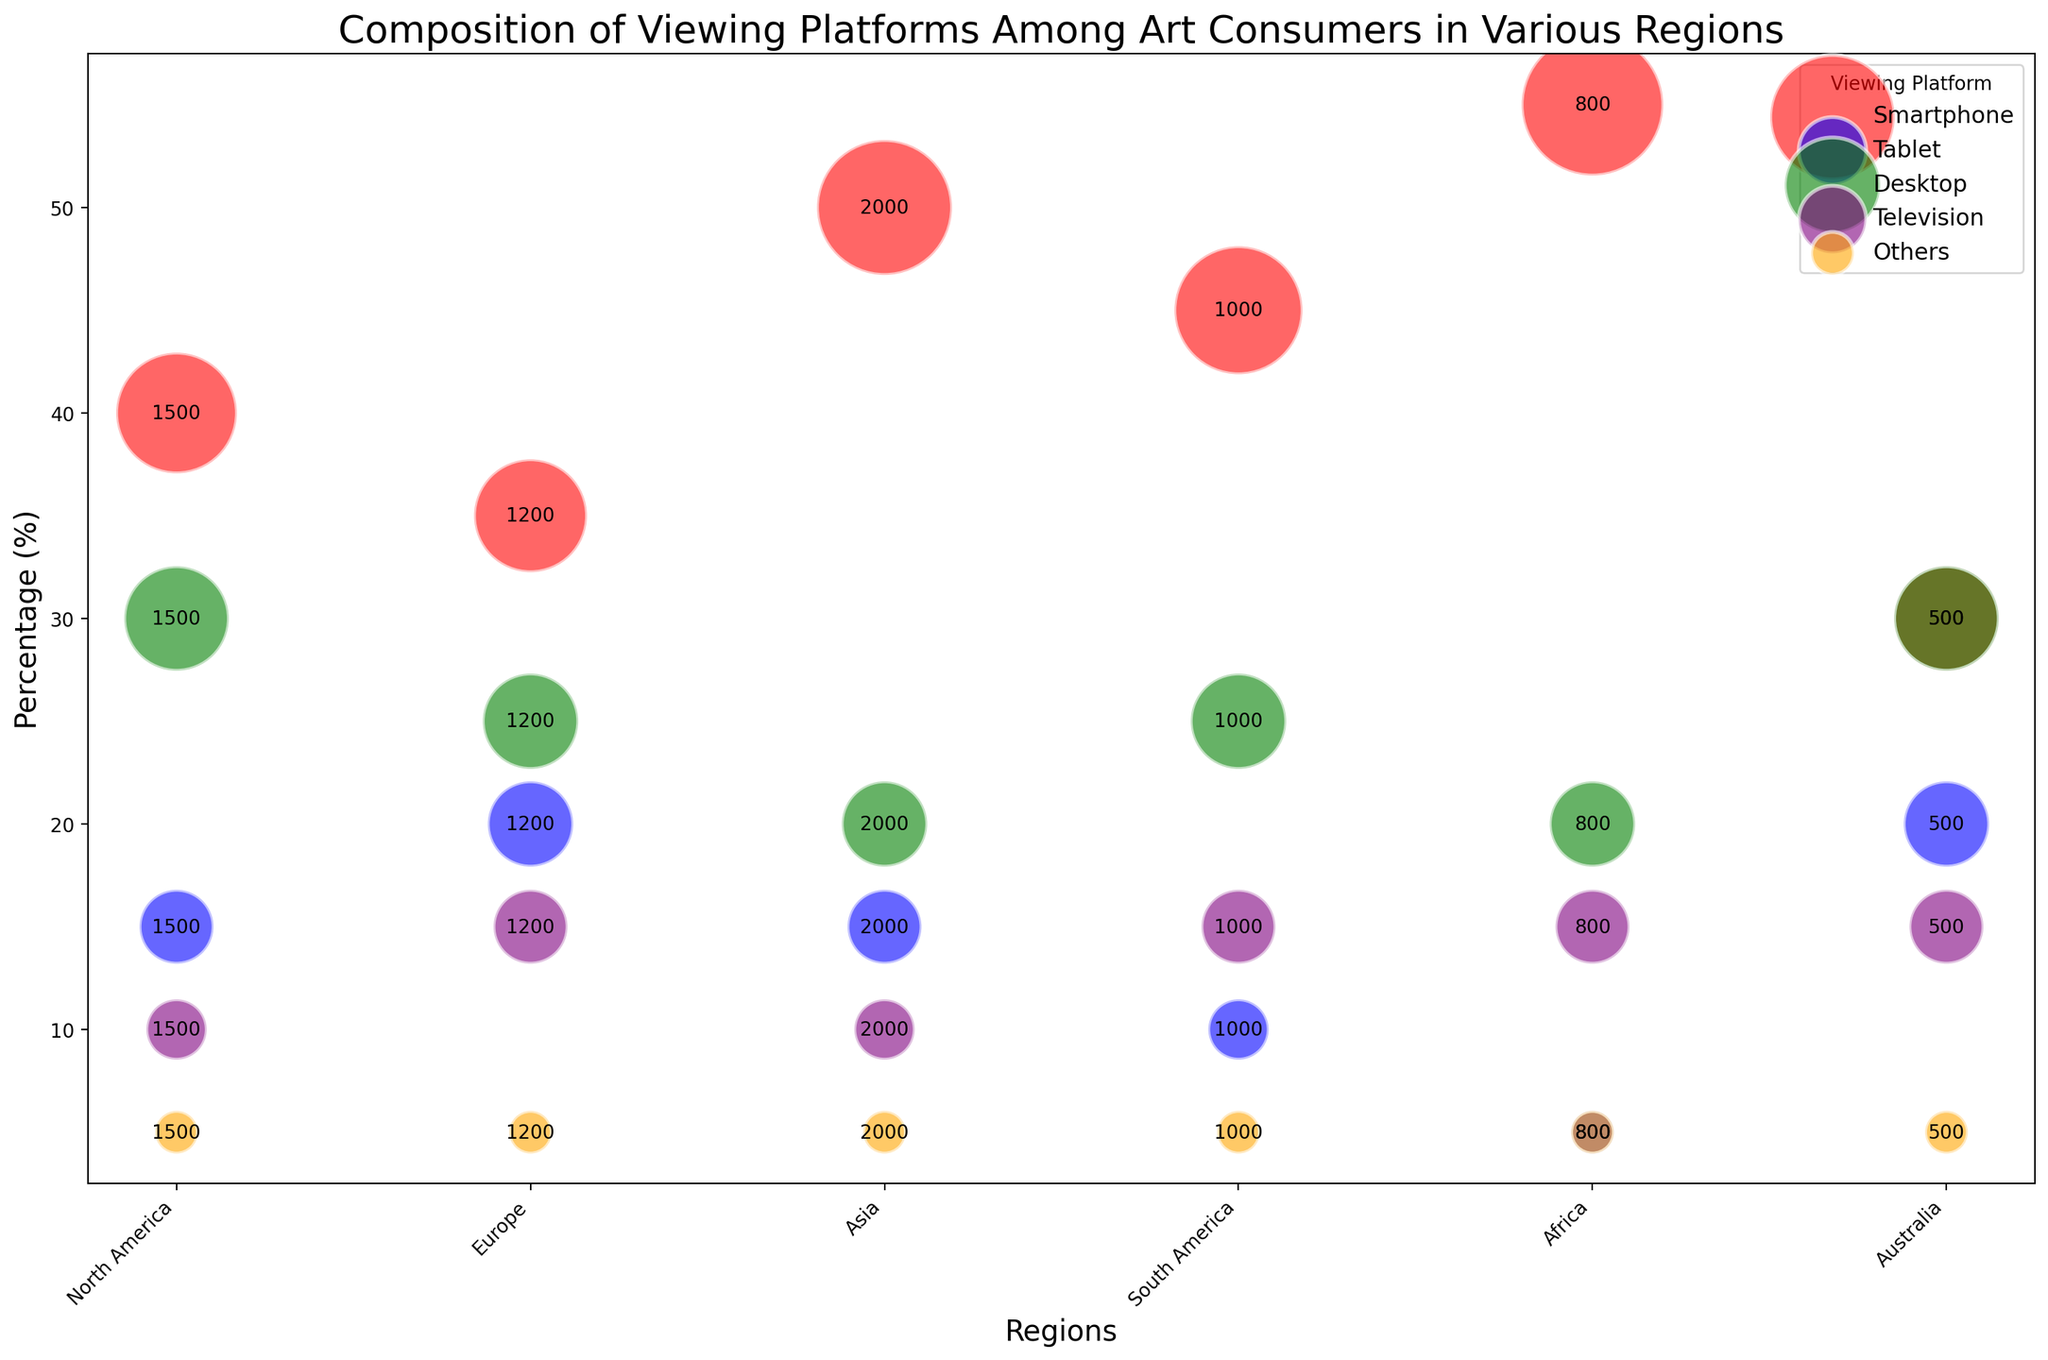What percentage of art consumers in North America use Smartphones? In the North America region, look for the Smartphone viewing platform's percentage.
Answer: 40% Which region has the highest percentage of art consumers using Smartphones? Compare the percentages of Smartphone usage across all regions: North America (40%), Europe (35%), Asia (50%), South America (45%), Africa (55%), and Australia (30%). The highest value is in Africa.
Answer: Africa How many art consumers in Asia use Desktops? Look for the number labeled on the bubble for Desktop users in the Asia region.
Answer: 2000 Between Europe and South America, which region has a higher percentage of Tablet users? Compare the Tablet usage percentages in Europe (20%) and South America (10%).
Answer: Europe Which region has the lowest overall percentage for the "Others" category? Compare the percentages for the "Others" category across all regions: North America (5%), Europe (5%), Asia (5%), South America (5%), Africa (5%), and Australia (5%). All regions have the same percentage.
Answer: All regions are equal What is the difference in the percentage of Smartphone users between Asia and Australia? Subtract the percentage value for Australia (30%) from Asia's percentage (50%).
Answer: 20% Which viewing platform is most popular in Europe? Compare the percentages of all viewing platforms in Europe: Smartphone (35%), Tablet (20%), Desktop (25%), Television (15%), Others (5%). The highest percentage is for Smartphones.
Answer: Smartphone How many regions have a 15% usage rate for Televisions? Count the regions that have a 15% percentage for Television usage: Europe, South America, Africa, and Australia.
Answer: 4 What is the combined percentage of art consumers using Desktops and Televisions in North America? Sum the percentages for Desktops (30%) and Televisions (10%) in North America.
Answer: 40% Which viewing platform has the smallest bubble in Africa? Compare the sizes of the bubbles for all platforms in Africa. The smallest is for Tablet users.
Answer: Tablet 